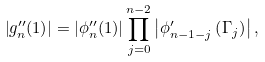<formula> <loc_0><loc_0><loc_500><loc_500>\left | g ^ { \prime \prime } _ { n } ( 1 ) \right | = \left | \phi ^ { \prime \prime } _ { n } ( 1 ) \right | \prod _ { j = 0 } ^ { n - 2 } \left | \phi ^ { \prime } _ { n - 1 - j } \left ( \Gamma _ { j } \right ) \right | ,</formula> 